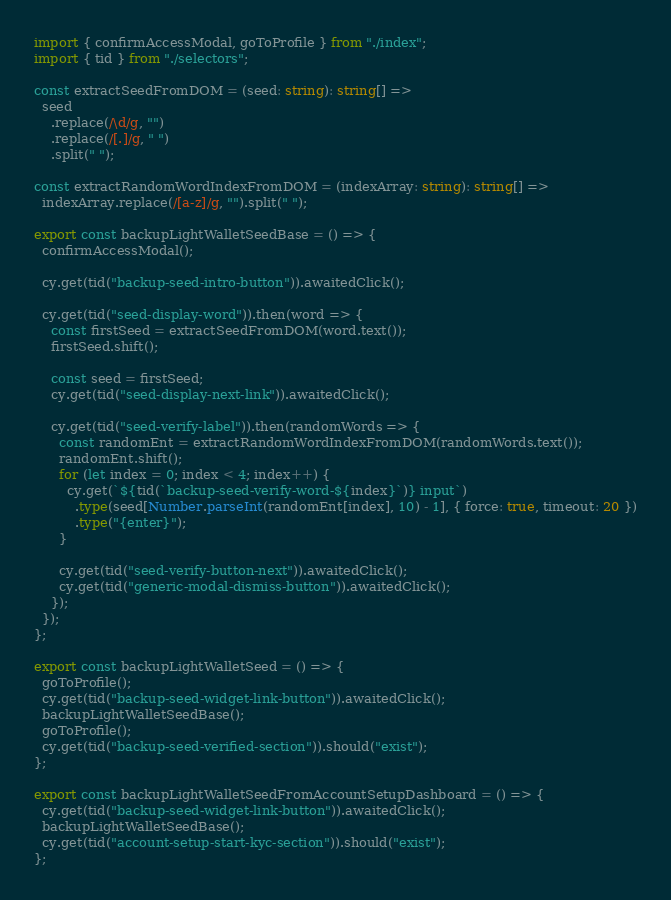<code> <loc_0><loc_0><loc_500><loc_500><_TypeScript_>import { confirmAccessModal, goToProfile } from "./index";
import { tid } from "./selectors";

const extractSeedFromDOM = (seed: string): string[] =>
  seed
    .replace(/\d/g, "")
    .replace(/[.]/g, " ")
    .split(" ");

const extractRandomWordIndexFromDOM = (indexArray: string): string[] =>
  indexArray.replace(/[a-z]/g, "").split(" ");

export const backupLightWalletSeedBase = () => {
  confirmAccessModal();

  cy.get(tid("backup-seed-intro-button")).awaitedClick();

  cy.get(tid("seed-display-word")).then(word => {
    const firstSeed = extractSeedFromDOM(word.text());
    firstSeed.shift();

    const seed = firstSeed;
    cy.get(tid("seed-display-next-link")).awaitedClick();

    cy.get(tid("seed-verify-label")).then(randomWords => {
      const randomEnt = extractRandomWordIndexFromDOM(randomWords.text());
      randomEnt.shift();
      for (let index = 0; index < 4; index++) {
        cy.get(`${tid(`backup-seed-verify-word-${index}`)} input`)
          .type(seed[Number.parseInt(randomEnt[index], 10) - 1], { force: true, timeout: 20 })
          .type("{enter}");
      }

      cy.get(tid("seed-verify-button-next")).awaitedClick();
      cy.get(tid("generic-modal-dismiss-button")).awaitedClick();
    });
  });
};

export const backupLightWalletSeed = () => {
  goToProfile();
  cy.get(tid("backup-seed-widget-link-button")).awaitedClick();
  backupLightWalletSeedBase();
  goToProfile();
  cy.get(tid("backup-seed-verified-section")).should("exist");
};

export const backupLightWalletSeedFromAccountSetupDashboard = () => {
  cy.get(tid("backup-seed-widget-link-button")).awaitedClick();
  backupLightWalletSeedBase();
  cy.get(tid("account-setup-start-kyc-section")).should("exist");
};
</code> 